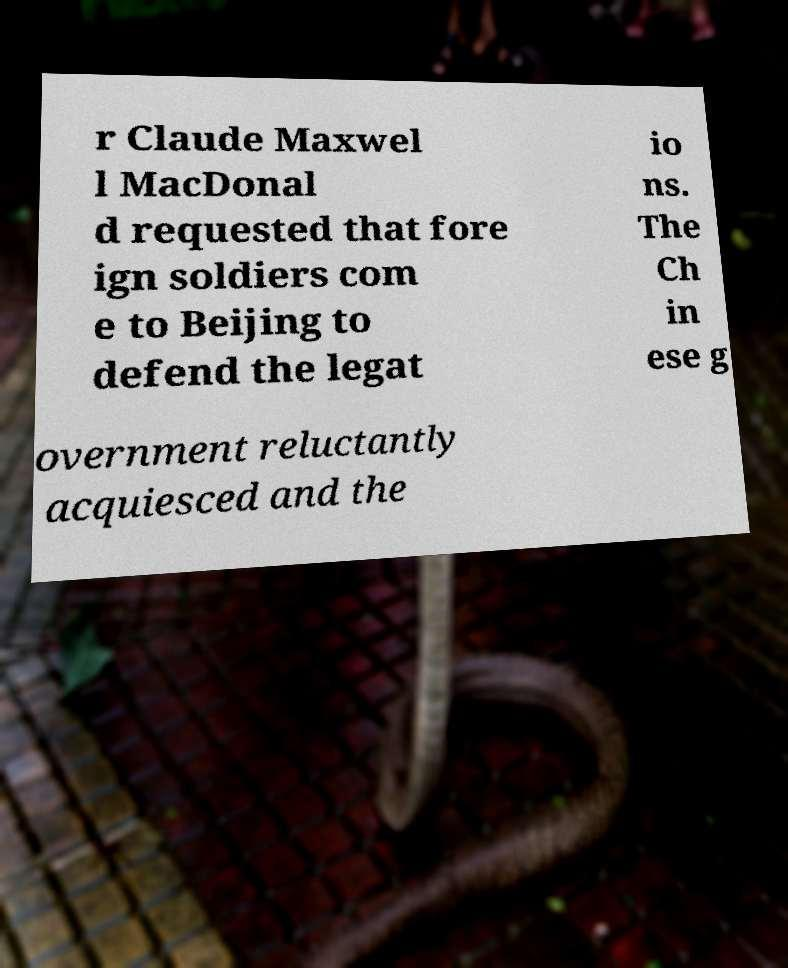Could you assist in decoding the text presented in this image and type it out clearly? r Claude Maxwel l MacDonal d requested that fore ign soldiers com e to Beijing to defend the legat io ns. The Ch in ese g overnment reluctantly acquiesced and the 